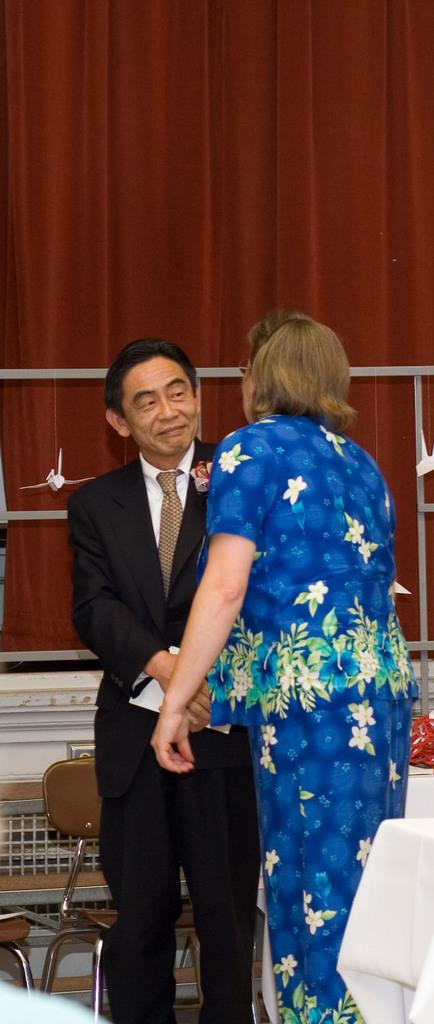How many people are in the image? There is a man and a woman in the image. What are the man and woman doing in the image? The man and woman are shaking hands in the image. What furniture is present in the image? There are chairs in the image. Is there any additional detail on the chairs? Yes, there is a cloth on the back of one of the chairs. What type of knife is being used by the man in the image? There is no knife present in the image. What is the income of the woman in the image? The income of the woman cannot be determined from the image. 